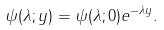<formula> <loc_0><loc_0><loc_500><loc_500>\psi ( \lambda ; y ) = \psi ( \lambda ; 0 ) e ^ { - \lambda y } .</formula> 